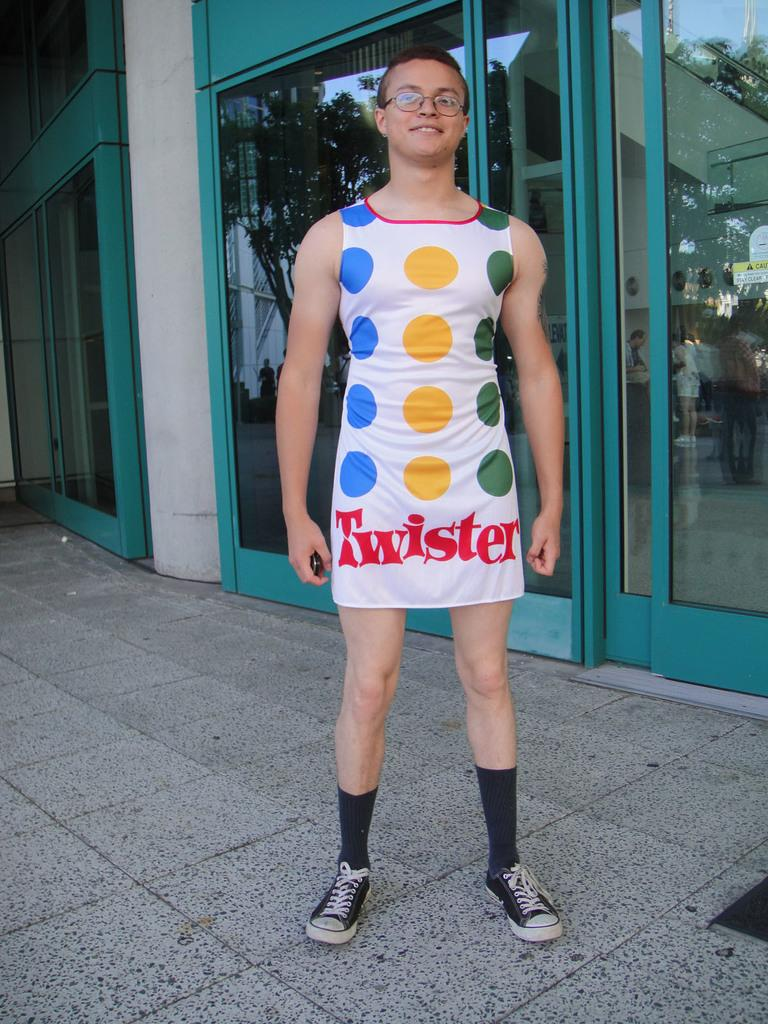<image>
Provide a brief description of the given image. Man wearing a dress that says Twister on it. 